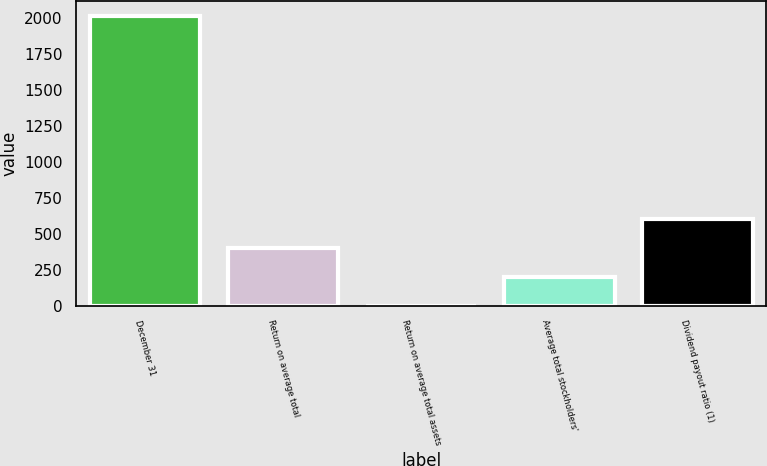Convert chart to OTSL. <chart><loc_0><loc_0><loc_500><loc_500><bar_chart><fcel>December 31<fcel>Return on average total<fcel>Return on average total assets<fcel>Average total stockholders'<fcel>Dividend payout ratio (1)<nl><fcel>2015<fcel>403.69<fcel>0.87<fcel>202.28<fcel>605.1<nl></chart> 